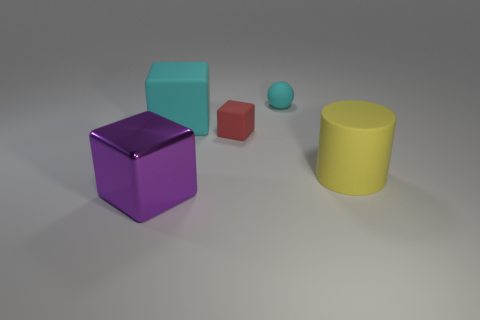Is there any other thing that has the same material as the big purple thing?
Provide a short and direct response. No. There is a thing behind the cyan rubber block; is there a small ball in front of it?
Your answer should be very brief. No. Does the small red rubber object that is behind the big yellow cylinder have the same shape as the large cyan object?
Make the answer very short. Yes. Are there any other things that have the same shape as the red object?
Provide a succinct answer. Yes. How many spheres are either big purple objects or big yellow objects?
Your answer should be very brief. 0. What number of tiny red metallic spheres are there?
Keep it short and to the point. 0. What is the size of the cyan matte object that is behind the large rubber object that is behind the big yellow rubber cylinder?
Offer a terse response. Small. What number of other objects are the same size as the cyan ball?
Ensure brevity in your answer.  1. How many large matte cubes are right of the big cyan rubber object?
Your response must be concise. 0. The ball is what size?
Keep it short and to the point. Small. 